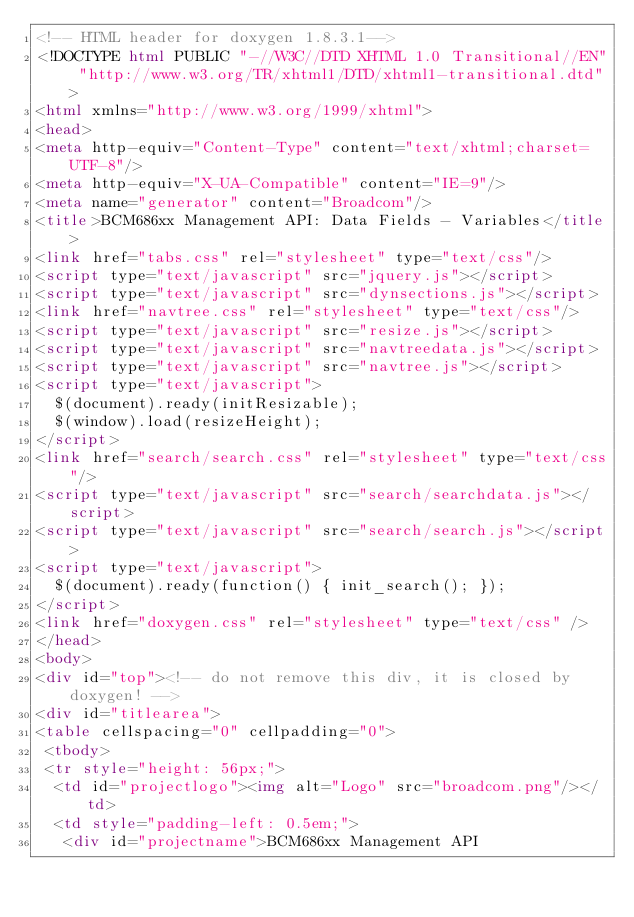Convert code to text. <code><loc_0><loc_0><loc_500><loc_500><_HTML_><!-- HTML header for doxygen 1.8.3.1-->
<!DOCTYPE html PUBLIC "-//W3C//DTD XHTML 1.0 Transitional//EN" "http://www.w3.org/TR/xhtml1/DTD/xhtml1-transitional.dtd">
<html xmlns="http://www.w3.org/1999/xhtml">
<head>
<meta http-equiv="Content-Type" content="text/xhtml;charset=UTF-8"/>
<meta http-equiv="X-UA-Compatible" content="IE=9"/>
<meta name="generator" content="Broadcom"/>
<title>BCM686xx Management API: Data Fields - Variables</title>
<link href="tabs.css" rel="stylesheet" type="text/css"/>
<script type="text/javascript" src="jquery.js"></script>
<script type="text/javascript" src="dynsections.js"></script>
<link href="navtree.css" rel="stylesheet" type="text/css"/>
<script type="text/javascript" src="resize.js"></script>
<script type="text/javascript" src="navtreedata.js"></script>
<script type="text/javascript" src="navtree.js"></script>
<script type="text/javascript">
  $(document).ready(initResizable);
  $(window).load(resizeHeight);
</script>
<link href="search/search.css" rel="stylesheet" type="text/css"/>
<script type="text/javascript" src="search/searchdata.js"></script>
<script type="text/javascript" src="search/search.js"></script>
<script type="text/javascript">
  $(document).ready(function() { init_search(); });
</script>
<link href="doxygen.css" rel="stylesheet" type="text/css" />
</head>
<body>
<div id="top"><!-- do not remove this div, it is closed by doxygen! -->
<div id="titlearea">
<table cellspacing="0" cellpadding="0">
 <tbody>
 <tr style="height: 56px;">
  <td id="projectlogo"><img alt="Logo" src="broadcom.png"/></td>
  <td style="padding-left: 0.5em;">
   <div id="projectname">BCM686xx Management API</code> 